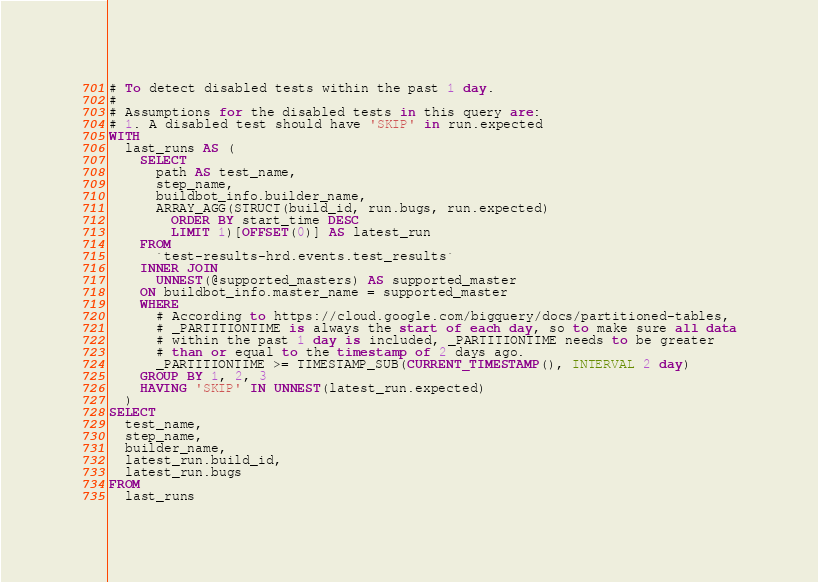<code> <loc_0><loc_0><loc_500><loc_500><_SQL_># To detect disabled tests within the past 1 day.
#
# Assumptions for the disabled tests in this query are:
# 1. A disabled test should have 'SKIP' in run.expected
WITH
  last_runs AS (
    SELECT
      path AS test_name,
      step_name,
      buildbot_info.builder_name,
      ARRAY_AGG(STRUCT(build_id, run.bugs, run.expected)
        ORDER BY start_time DESC
        LIMIT 1)[OFFSET(0)] AS latest_run
    FROM
      `test-results-hrd.events.test_results`
    INNER JOIN
      UNNEST(@supported_masters) AS supported_master
    ON buildbot_info.master_name = supported_master
    WHERE
      # According to https://cloud.google.com/bigquery/docs/partitioned-tables,
      # _PARTITIONTIME is always the start of each day, so to make sure all data
      # within the past 1 day is included, _PARTITIONTIME needs to be greater
      # than or equal to the timestamp of 2 days ago.
      _PARTITIONTIME >= TIMESTAMP_SUB(CURRENT_TIMESTAMP(), INTERVAL 2 day)
    GROUP BY 1, 2, 3
    HAVING 'SKIP' IN UNNEST(latest_run.expected)
  )
SELECT
  test_name,
  step_name,
  builder_name,
  latest_run.build_id,
  latest_run.bugs
FROM
  last_runs
</code> 